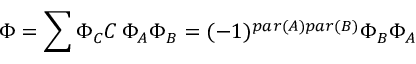<formula> <loc_0><loc_0><loc_500><loc_500>\Phi = \sum \Phi _ { C } C \, \Phi _ { A } \Phi _ { B } = ( - 1 ) ^ { p a r ( A ) p a r ( B ) } \Phi _ { B } \Phi _ { A }</formula> 